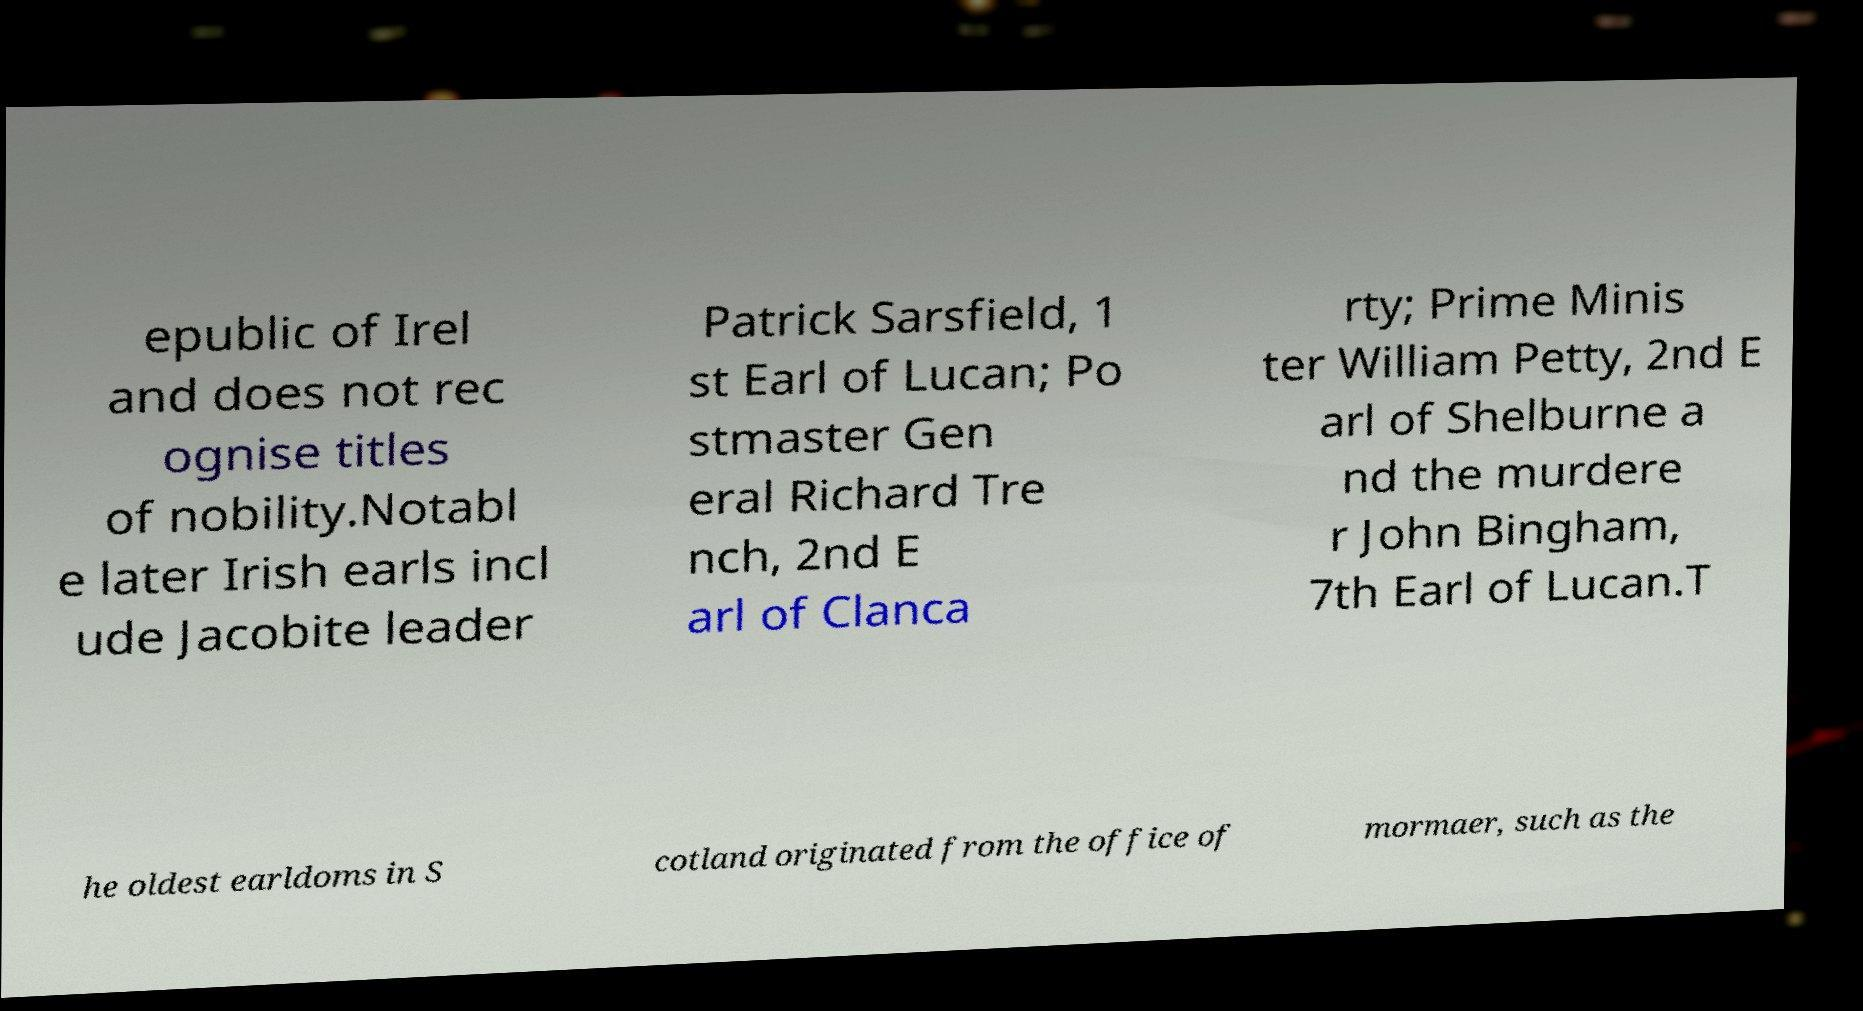Can you accurately transcribe the text from the provided image for me? epublic of Irel and does not rec ognise titles of nobility.Notabl e later Irish earls incl ude Jacobite leader Patrick Sarsfield, 1 st Earl of Lucan; Po stmaster Gen eral Richard Tre nch, 2nd E arl of Clanca rty; Prime Minis ter William Petty, 2nd E arl of Shelburne a nd the murdere r John Bingham, 7th Earl of Lucan.T he oldest earldoms in S cotland originated from the office of mormaer, such as the 